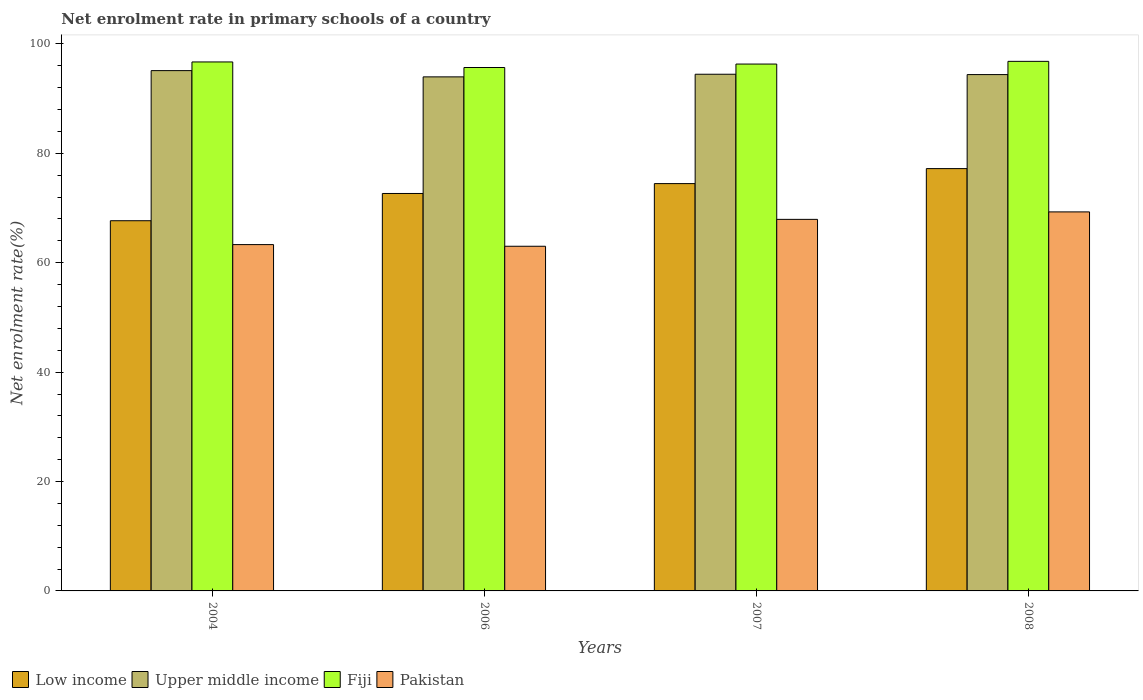How many different coloured bars are there?
Your answer should be compact. 4. How many groups of bars are there?
Provide a succinct answer. 4. Are the number of bars on each tick of the X-axis equal?
Your answer should be compact. Yes. How many bars are there on the 2nd tick from the right?
Offer a very short reply. 4. What is the label of the 2nd group of bars from the left?
Your answer should be very brief. 2006. What is the net enrolment rate in primary schools in Pakistan in 2006?
Provide a succinct answer. 63.01. Across all years, what is the maximum net enrolment rate in primary schools in Pakistan?
Offer a very short reply. 69.29. Across all years, what is the minimum net enrolment rate in primary schools in Pakistan?
Your response must be concise. 63.01. What is the total net enrolment rate in primary schools in Pakistan in the graph?
Provide a short and direct response. 263.56. What is the difference between the net enrolment rate in primary schools in Pakistan in 2006 and that in 2008?
Your response must be concise. -6.28. What is the difference between the net enrolment rate in primary schools in Pakistan in 2007 and the net enrolment rate in primary schools in Fiji in 2006?
Provide a succinct answer. -27.76. What is the average net enrolment rate in primary schools in Fiji per year?
Your answer should be compact. 96.39. In the year 2006, what is the difference between the net enrolment rate in primary schools in Upper middle income and net enrolment rate in primary schools in Fiji?
Your answer should be compact. -1.71. In how many years, is the net enrolment rate in primary schools in Fiji greater than 32 %?
Your answer should be very brief. 4. What is the ratio of the net enrolment rate in primary schools in Low income in 2006 to that in 2007?
Provide a succinct answer. 0.98. Is the net enrolment rate in primary schools in Low income in 2004 less than that in 2008?
Provide a short and direct response. Yes. What is the difference between the highest and the second highest net enrolment rate in primary schools in Fiji?
Your response must be concise. 0.11. What is the difference between the highest and the lowest net enrolment rate in primary schools in Low income?
Ensure brevity in your answer.  9.53. In how many years, is the net enrolment rate in primary schools in Pakistan greater than the average net enrolment rate in primary schools in Pakistan taken over all years?
Your response must be concise. 2. Is the sum of the net enrolment rate in primary schools in Upper middle income in 2006 and 2008 greater than the maximum net enrolment rate in primary schools in Pakistan across all years?
Provide a succinct answer. Yes. Is it the case that in every year, the sum of the net enrolment rate in primary schools in Fiji and net enrolment rate in primary schools in Upper middle income is greater than the sum of net enrolment rate in primary schools in Pakistan and net enrolment rate in primary schools in Low income?
Your answer should be compact. No. What does the 1st bar from the left in 2006 represents?
Make the answer very short. Low income. Is it the case that in every year, the sum of the net enrolment rate in primary schools in Low income and net enrolment rate in primary schools in Pakistan is greater than the net enrolment rate in primary schools in Upper middle income?
Provide a short and direct response. Yes. Does the graph contain grids?
Keep it short and to the point. No. Where does the legend appear in the graph?
Your answer should be compact. Bottom left. How are the legend labels stacked?
Give a very brief answer. Horizontal. What is the title of the graph?
Provide a short and direct response. Net enrolment rate in primary schools of a country. What is the label or title of the X-axis?
Offer a terse response. Years. What is the label or title of the Y-axis?
Provide a short and direct response. Net enrolment rate(%). What is the Net enrolment rate(%) in Low income in 2004?
Provide a succinct answer. 67.68. What is the Net enrolment rate(%) of Upper middle income in 2004?
Your answer should be compact. 95.12. What is the Net enrolment rate(%) of Fiji in 2004?
Offer a very short reply. 96.71. What is the Net enrolment rate(%) of Pakistan in 2004?
Your answer should be very brief. 63.32. What is the Net enrolment rate(%) of Low income in 2006?
Ensure brevity in your answer.  72.66. What is the Net enrolment rate(%) of Upper middle income in 2006?
Your answer should be compact. 93.98. What is the Net enrolment rate(%) in Fiji in 2006?
Give a very brief answer. 95.69. What is the Net enrolment rate(%) of Pakistan in 2006?
Offer a very short reply. 63.01. What is the Net enrolment rate(%) in Low income in 2007?
Offer a very short reply. 74.47. What is the Net enrolment rate(%) of Upper middle income in 2007?
Your answer should be very brief. 94.46. What is the Net enrolment rate(%) of Fiji in 2007?
Offer a very short reply. 96.33. What is the Net enrolment rate(%) of Pakistan in 2007?
Provide a succinct answer. 67.93. What is the Net enrolment rate(%) of Low income in 2008?
Offer a very short reply. 77.21. What is the Net enrolment rate(%) of Upper middle income in 2008?
Give a very brief answer. 94.4. What is the Net enrolment rate(%) of Fiji in 2008?
Provide a succinct answer. 96.82. What is the Net enrolment rate(%) of Pakistan in 2008?
Give a very brief answer. 69.29. Across all years, what is the maximum Net enrolment rate(%) of Low income?
Offer a very short reply. 77.21. Across all years, what is the maximum Net enrolment rate(%) of Upper middle income?
Provide a short and direct response. 95.12. Across all years, what is the maximum Net enrolment rate(%) in Fiji?
Make the answer very short. 96.82. Across all years, what is the maximum Net enrolment rate(%) in Pakistan?
Provide a short and direct response. 69.29. Across all years, what is the minimum Net enrolment rate(%) in Low income?
Your answer should be compact. 67.68. Across all years, what is the minimum Net enrolment rate(%) of Upper middle income?
Keep it short and to the point. 93.98. Across all years, what is the minimum Net enrolment rate(%) in Fiji?
Your answer should be very brief. 95.69. Across all years, what is the minimum Net enrolment rate(%) of Pakistan?
Make the answer very short. 63.01. What is the total Net enrolment rate(%) in Low income in the graph?
Ensure brevity in your answer.  292.02. What is the total Net enrolment rate(%) in Upper middle income in the graph?
Keep it short and to the point. 377.97. What is the total Net enrolment rate(%) of Fiji in the graph?
Make the answer very short. 385.55. What is the total Net enrolment rate(%) in Pakistan in the graph?
Provide a short and direct response. 263.56. What is the difference between the Net enrolment rate(%) of Low income in 2004 and that in 2006?
Your response must be concise. -4.98. What is the difference between the Net enrolment rate(%) in Upper middle income in 2004 and that in 2006?
Keep it short and to the point. 1.14. What is the difference between the Net enrolment rate(%) of Fiji in 2004 and that in 2006?
Offer a terse response. 1.02. What is the difference between the Net enrolment rate(%) of Pakistan in 2004 and that in 2006?
Provide a succinct answer. 0.3. What is the difference between the Net enrolment rate(%) in Low income in 2004 and that in 2007?
Keep it short and to the point. -6.79. What is the difference between the Net enrolment rate(%) of Upper middle income in 2004 and that in 2007?
Make the answer very short. 0.66. What is the difference between the Net enrolment rate(%) of Fiji in 2004 and that in 2007?
Provide a short and direct response. 0.39. What is the difference between the Net enrolment rate(%) in Pakistan in 2004 and that in 2007?
Ensure brevity in your answer.  -4.61. What is the difference between the Net enrolment rate(%) of Low income in 2004 and that in 2008?
Provide a short and direct response. -9.53. What is the difference between the Net enrolment rate(%) in Upper middle income in 2004 and that in 2008?
Give a very brief answer. 0.72. What is the difference between the Net enrolment rate(%) in Fiji in 2004 and that in 2008?
Your answer should be very brief. -0.11. What is the difference between the Net enrolment rate(%) in Pakistan in 2004 and that in 2008?
Your response must be concise. -5.98. What is the difference between the Net enrolment rate(%) in Low income in 2006 and that in 2007?
Your answer should be compact. -1.8. What is the difference between the Net enrolment rate(%) of Upper middle income in 2006 and that in 2007?
Provide a short and direct response. -0.48. What is the difference between the Net enrolment rate(%) of Fiji in 2006 and that in 2007?
Offer a very short reply. -0.63. What is the difference between the Net enrolment rate(%) of Pakistan in 2006 and that in 2007?
Your response must be concise. -4.92. What is the difference between the Net enrolment rate(%) of Low income in 2006 and that in 2008?
Your answer should be compact. -4.55. What is the difference between the Net enrolment rate(%) of Upper middle income in 2006 and that in 2008?
Offer a terse response. -0.42. What is the difference between the Net enrolment rate(%) in Fiji in 2006 and that in 2008?
Your answer should be very brief. -1.13. What is the difference between the Net enrolment rate(%) of Pakistan in 2006 and that in 2008?
Keep it short and to the point. -6.28. What is the difference between the Net enrolment rate(%) in Low income in 2007 and that in 2008?
Your answer should be compact. -2.74. What is the difference between the Net enrolment rate(%) of Upper middle income in 2007 and that in 2008?
Your answer should be compact. 0.06. What is the difference between the Net enrolment rate(%) of Fiji in 2007 and that in 2008?
Ensure brevity in your answer.  -0.49. What is the difference between the Net enrolment rate(%) of Pakistan in 2007 and that in 2008?
Make the answer very short. -1.36. What is the difference between the Net enrolment rate(%) in Low income in 2004 and the Net enrolment rate(%) in Upper middle income in 2006?
Your answer should be very brief. -26.3. What is the difference between the Net enrolment rate(%) of Low income in 2004 and the Net enrolment rate(%) of Fiji in 2006?
Give a very brief answer. -28.01. What is the difference between the Net enrolment rate(%) in Low income in 2004 and the Net enrolment rate(%) in Pakistan in 2006?
Provide a short and direct response. 4.67. What is the difference between the Net enrolment rate(%) of Upper middle income in 2004 and the Net enrolment rate(%) of Fiji in 2006?
Offer a terse response. -0.57. What is the difference between the Net enrolment rate(%) in Upper middle income in 2004 and the Net enrolment rate(%) in Pakistan in 2006?
Ensure brevity in your answer.  32.11. What is the difference between the Net enrolment rate(%) in Fiji in 2004 and the Net enrolment rate(%) in Pakistan in 2006?
Your answer should be very brief. 33.7. What is the difference between the Net enrolment rate(%) in Low income in 2004 and the Net enrolment rate(%) in Upper middle income in 2007?
Your answer should be compact. -26.78. What is the difference between the Net enrolment rate(%) in Low income in 2004 and the Net enrolment rate(%) in Fiji in 2007?
Ensure brevity in your answer.  -28.65. What is the difference between the Net enrolment rate(%) in Low income in 2004 and the Net enrolment rate(%) in Pakistan in 2007?
Your answer should be compact. -0.25. What is the difference between the Net enrolment rate(%) in Upper middle income in 2004 and the Net enrolment rate(%) in Fiji in 2007?
Offer a terse response. -1.2. What is the difference between the Net enrolment rate(%) of Upper middle income in 2004 and the Net enrolment rate(%) of Pakistan in 2007?
Ensure brevity in your answer.  27.19. What is the difference between the Net enrolment rate(%) in Fiji in 2004 and the Net enrolment rate(%) in Pakistan in 2007?
Ensure brevity in your answer.  28.78. What is the difference between the Net enrolment rate(%) of Low income in 2004 and the Net enrolment rate(%) of Upper middle income in 2008?
Give a very brief answer. -26.72. What is the difference between the Net enrolment rate(%) of Low income in 2004 and the Net enrolment rate(%) of Fiji in 2008?
Offer a very short reply. -29.14. What is the difference between the Net enrolment rate(%) in Low income in 2004 and the Net enrolment rate(%) in Pakistan in 2008?
Offer a terse response. -1.61. What is the difference between the Net enrolment rate(%) in Upper middle income in 2004 and the Net enrolment rate(%) in Fiji in 2008?
Offer a terse response. -1.69. What is the difference between the Net enrolment rate(%) in Upper middle income in 2004 and the Net enrolment rate(%) in Pakistan in 2008?
Offer a very short reply. 25.83. What is the difference between the Net enrolment rate(%) of Fiji in 2004 and the Net enrolment rate(%) of Pakistan in 2008?
Provide a succinct answer. 27.42. What is the difference between the Net enrolment rate(%) of Low income in 2006 and the Net enrolment rate(%) of Upper middle income in 2007?
Make the answer very short. -21.8. What is the difference between the Net enrolment rate(%) in Low income in 2006 and the Net enrolment rate(%) in Fiji in 2007?
Ensure brevity in your answer.  -23.66. What is the difference between the Net enrolment rate(%) of Low income in 2006 and the Net enrolment rate(%) of Pakistan in 2007?
Provide a short and direct response. 4.73. What is the difference between the Net enrolment rate(%) of Upper middle income in 2006 and the Net enrolment rate(%) of Fiji in 2007?
Your response must be concise. -2.34. What is the difference between the Net enrolment rate(%) in Upper middle income in 2006 and the Net enrolment rate(%) in Pakistan in 2007?
Offer a very short reply. 26.05. What is the difference between the Net enrolment rate(%) of Fiji in 2006 and the Net enrolment rate(%) of Pakistan in 2007?
Your answer should be very brief. 27.76. What is the difference between the Net enrolment rate(%) in Low income in 2006 and the Net enrolment rate(%) in Upper middle income in 2008?
Ensure brevity in your answer.  -21.74. What is the difference between the Net enrolment rate(%) in Low income in 2006 and the Net enrolment rate(%) in Fiji in 2008?
Provide a succinct answer. -24.16. What is the difference between the Net enrolment rate(%) in Low income in 2006 and the Net enrolment rate(%) in Pakistan in 2008?
Make the answer very short. 3.37. What is the difference between the Net enrolment rate(%) of Upper middle income in 2006 and the Net enrolment rate(%) of Fiji in 2008?
Offer a terse response. -2.84. What is the difference between the Net enrolment rate(%) in Upper middle income in 2006 and the Net enrolment rate(%) in Pakistan in 2008?
Offer a very short reply. 24.69. What is the difference between the Net enrolment rate(%) in Fiji in 2006 and the Net enrolment rate(%) in Pakistan in 2008?
Offer a terse response. 26.4. What is the difference between the Net enrolment rate(%) of Low income in 2007 and the Net enrolment rate(%) of Upper middle income in 2008?
Your response must be concise. -19.93. What is the difference between the Net enrolment rate(%) in Low income in 2007 and the Net enrolment rate(%) in Fiji in 2008?
Provide a short and direct response. -22.35. What is the difference between the Net enrolment rate(%) of Low income in 2007 and the Net enrolment rate(%) of Pakistan in 2008?
Your answer should be very brief. 5.17. What is the difference between the Net enrolment rate(%) in Upper middle income in 2007 and the Net enrolment rate(%) in Fiji in 2008?
Make the answer very short. -2.36. What is the difference between the Net enrolment rate(%) in Upper middle income in 2007 and the Net enrolment rate(%) in Pakistan in 2008?
Make the answer very short. 25.17. What is the difference between the Net enrolment rate(%) of Fiji in 2007 and the Net enrolment rate(%) of Pakistan in 2008?
Your answer should be compact. 27.03. What is the average Net enrolment rate(%) in Low income per year?
Make the answer very short. 73.01. What is the average Net enrolment rate(%) in Upper middle income per year?
Offer a very short reply. 94.49. What is the average Net enrolment rate(%) in Fiji per year?
Give a very brief answer. 96.39. What is the average Net enrolment rate(%) in Pakistan per year?
Your response must be concise. 65.89. In the year 2004, what is the difference between the Net enrolment rate(%) in Low income and Net enrolment rate(%) in Upper middle income?
Offer a very short reply. -27.44. In the year 2004, what is the difference between the Net enrolment rate(%) in Low income and Net enrolment rate(%) in Fiji?
Make the answer very short. -29.03. In the year 2004, what is the difference between the Net enrolment rate(%) of Low income and Net enrolment rate(%) of Pakistan?
Provide a short and direct response. 4.36. In the year 2004, what is the difference between the Net enrolment rate(%) in Upper middle income and Net enrolment rate(%) in Fiji?
Your answer should be compact. -1.59. In the year 2004, what is the difference between the Net enrolment rate(%) of Upper middle income and Net enrolment rate(%) of Pakistan?
Ensure brevity in your answer.  31.81. In the year 2004, what is the difference between the Net enrolment rate(%) of Fiji and Net enrolment rate(%) of Pakistan?
Your answer should be compact. 33.39. In the year 2006, what is the difference between the Net enrolment rate(%) of Low income and Net enrolment rate(%) of Upper middle income?
Make the answer very short. -21.32. In the year 2006, what is the difference between the Net enrolment rate(%) in Low income and Net enrolment rate(%) in Fiji?
Offer a very short reply. -23.03. In the year 2006, what is the difference between the Net enrolment rate(%) of Low income and Net enrolment rate(%) of Pakistan?
Offer a very short reply. 9.65. In the year 2006, what is the difference between the Net enrolment rate(%) in Upper middle income and Net enrolment rate(%) in Fiji?
Ensure brevity in your answer.  -1.71. In the year 2006, what is the difference between the Net enrolment rate(%) in Upper middle income and Net enrolment rate(%) in Pakistan?
Offer a terse response. 30.97. In the year 2006, what is the difference between the Net enrolment rate(%) of Fiji and Net enrolment rate(%) of Pakistan?
Keep it short and to the point. 32.68. In the year 2007, what is the difference between the Net enrolment rate(%) in Low income and Net enrolment rate(%) in Upper middle income?
Offer a terse response. -19.99. In the year 2007, what is the difference between the Net enrolment rate(%) in Low income and Net enrolment rate(%) in Fiji?
Provide a short and direct response. -21.86. In the year 2007, what is the difference between the Net enrolment rate(%) of Low income and Net enrolment rate(%) of Pakistan?
Your answer should be very brief. 6.54. In the year 2007, what is the difference between the Net enrolment rate(%) in Upper middle income and Net enrolment rate(%) in Fiji?
Provide a succinct answer. -1.86. In the year 2007, what is the difference between the Net enrolment rate(%) of Upper middle income and Net enrolment rate(%) of Pakistan?
Your answer should be compact. 26.53. In the year 2007, what is the difference between the Net enrolment rate(%) in Fiji and Net enrolment rate(%) in Pakistan?
Provide a short and direct response. 28.4. In the year 2008, what is the difference between the Net enrolment rate(%) in Low income and Net enrolment rate(%) in Upper middle income?
Your answer should be compact. -17.19. In the year 2008, what is the difference between the Net enrolment rate(%) of Low income and Net enrolment rate(%) of Fiji?
Offer a terse response. -19.61. In the year 2008, what is the difference between the Net enrolment rate(%) of Low income and Net enrolment rate(%) of Pakistan?
Offer a very short reply. 7.92. In the year 2008, what is the difference between the Net enrolment rate(%) of Upper middle income and Net enrolment rate(%) of Fiji?
Ensure brevity in your answer.  -2.42. In the year 2008, what is the difference between the Net enrolment rate(%) of Upper middle income and Net enrolment rate(%) of Pakistan?
Provide a short and direct response. 25.11. In the year 2008, what is the difference between the Net enrolment rate(%) of Fiji and Net enrolment rate(%) of Pakistan?
Your answer should be compact. 27.52. What is the ratio of the Net enrolment rate(%) in Low income in 2004 to that in 2006?
Your answer should be very brief. 0.93. What is the ratio of the Net enrolment rate(%) of Upper middle income in 2004 to that in 2006?
Offer a very short reply. 1.01. What is the ratio of the Net enrolment rate(%) of Fiji in 2004 to that in 2006?
Your answer should be compact. 1.01. What is the ratio of the Net enrolment rate(%) in Pakistan in 2004 to that in 2006?
Your answer should be compact. 1. What is the ratio of the Net enrolment rate(%) of Low income in 2004 to that in 2007?
Ensure brevity in your answer.  0.91. What is the ratio of the Net enrolment rate(%) of Pakistan in 2004 to that in 2007?
Ensure brevity in your answer.  0.93. What is the ratio of the Net enrolment rate(%) of Low income in 2004 to that in 2008?
Provide a succinct answer. 0.88. What is the ratio of the Net enrolment rate(%) of Upper middle income in 2004 to that in 2008?
Offer a very short reply. 1.01. What is the ratio of the Net enrolment rate(%) of Fiji in 2004 to that in 2008?
Make the answer very short. 1. What is the ratio of the Net enrolment rate(%) in Pakistan in 2004 to that in 2008?
Ensure brevity in your answer.  0.91. What is the ratio of the Net enrolment rate(%) of Low income in 2006 to that in 2007?
Your answer should be compact. 0.98. What is the ratio of the Net enrolment rate(%) in Upper middle income in 2006 to that in 2007?
Offer a terse response. 0.99. What is the ratio of the Net enrolment rate(%) of Pakistan in 2006 to that in 2007?
Offer a terse response. 0.93. What is the ratio of the Net enrolment rate(%) in Low income in 2006 to that in 2008?
Your response must be concise. 0.94. What is the ratio of the Net enrolment rate(%) of Fiji in 2006 to that in 2008?
Ensure brevity in your answer.  0.99. What is the ratio of the Net enrolment rate(%) of Pakistan in 2006 to that in 2008?
Keep it short and to the point. 0.91. What is the ratio of the Net enrolment rate(%) in Low income in 2007 to that in 2008?
Your answer should be very brief. 0.96. What is the ratio of the Net enrolment rate(%) in Upper middle income in 2007 to that in 2008?
Your answer should be compact. 1. What is the ratio of the Net enrolment rate(%) in Pakistan in 2007 to that in 2008?
Provide a short and direct response. 0.98. What is the difference between the highest and the second highest Net enrolment rate(%) of Low income?
Offer a very short reply. 2.74. What is the difference between the highest and the second highest Net enrolment rate(%) of Upper middle income?
Provide a succinct answer. 0.66. What is the difference between the highest and the second highest Net enrolment rate(%) in Fiji?
Provide a succinct answer. 0.11. What is the difference between the highest and the second highest Net enrolment rate(%) of Pakistan?
Your answer should be compact. 1.36. What is the difference between the highest and the lowest Net enrolment rate(%) in Low income?
Provide a short and direct response. 9.53. What is the difference between the highest and the lowest Net enrolment rate(%) in Upper middle income?
Make the answer very short. 1.14. What is the difference between the highest and the lowest Net enrolment rate(%) of Fiji?
Your answer should be compact. 1.13. What is the difference between the highest and the lowest Net enrolment rate(%) in Pakistan?
Your answer should be compact. 6.28. 